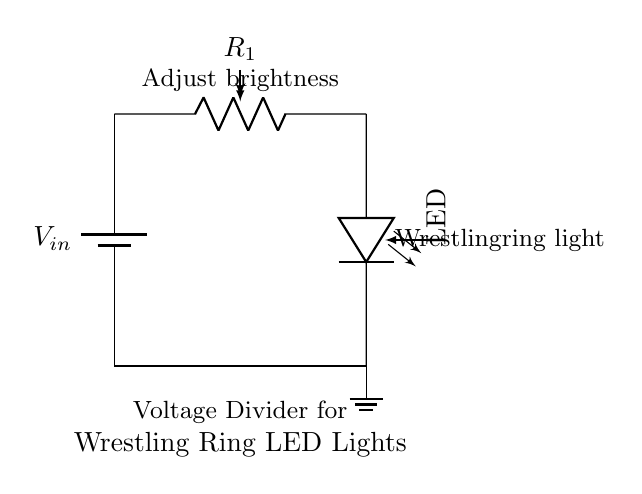What is the role of the potentiometer in this circuit? The potentiometer, labeled as R1, acts as a variable resistor, allowing the user to adjust the resistance in the circuit, which in turn varies the brightness of the LED.
Answer: Variable resistor What does the LED symbolize in the circuit? The LED represents the light source in the circuit, which illuminates when current passes through it. The brightness can be adjusted by changing the resistance of R1.
Answer: Light source What is the purpose of the voltage divider in this setup? The voltage divider reduces the input voltage to a lower value suitable for the LED, allowing for control over the LED's brightness by dividing the voltage across R1 and the LED.
Answer: Brightness control If R1 is set to maximum resistance, what happens to the LED? If R1 is set to maximum resistance, the current through the LED decreases significantly, potentially causing the LED to go off or emit very low light.
Answer: LED turns off What is the function of the battery in this circuit? The battery provides the necessary electrical energy (voltage) to power the circuit and enable the flow of current through the LED.
Answer: Power supply How is the brightness of the LED adjusted in this circuit? The brightness is adjusted by turning the potentiometer (R1), which changes the resistance and hence alters the amount of current flowing through the LED.
Answer: By adjusting R1 